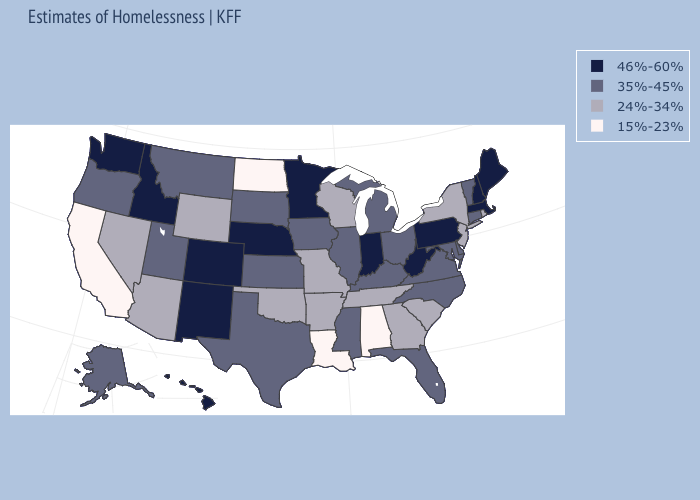Among the states that border West Virginia , which have the lowest value?
Give a very brief answer. Kentucky, Maryland, Ohio, Virginia. Does North Carolina have a higher value than Colorado?
Give a very brief answer. No. What is the value of New Jersey?
Write a very short answer. 24%-34%. Name the states that have a value in the range 24%-34%?
Keep it brief. Arizona, Arkansas, Georgia, Missouri, Nevada, New Jersey, New York, Oklahoma, Rhode Island, South Carolina, Tennessee, Wisconsin, Wyoming. What is the lowest value in the Northeast?
Concise answer only. 24%-34%. Among the states that border Pennsylvania , does Maryland have the highest value?
Quick response, please. No. Which states have the lowest value in the USA?
Write a very short answer. Alabama, California, Louisiana, North Dakota. What is the lowest value in the USA?
Write a very short answer. 15%-23%. Does the map have missing data?
Give a very brief answer. No. Which states have the lowest value in the Northeast?
Answer briefly. New Jersey, New York, Rhode Island. What is the value of Texas?
Short answer required. 35%-45%. Does Alabama have a higher value than Utah?
Write a very short answer. No. What is the value of Colorado?
Short answer required. 46%-60%. Does Delaware have a lower value than Colorado?
Give a very brief answer. Yes. Name the states that have a value in the range 46%-60%?
Quick response, please. Colorado, Hawaii, Idaho, Indiana, Maine, Massachusetts, Minnesota, Nebraska, New Hampshire, New Mexico, Pennsylvania, Washington, West Virginia. 